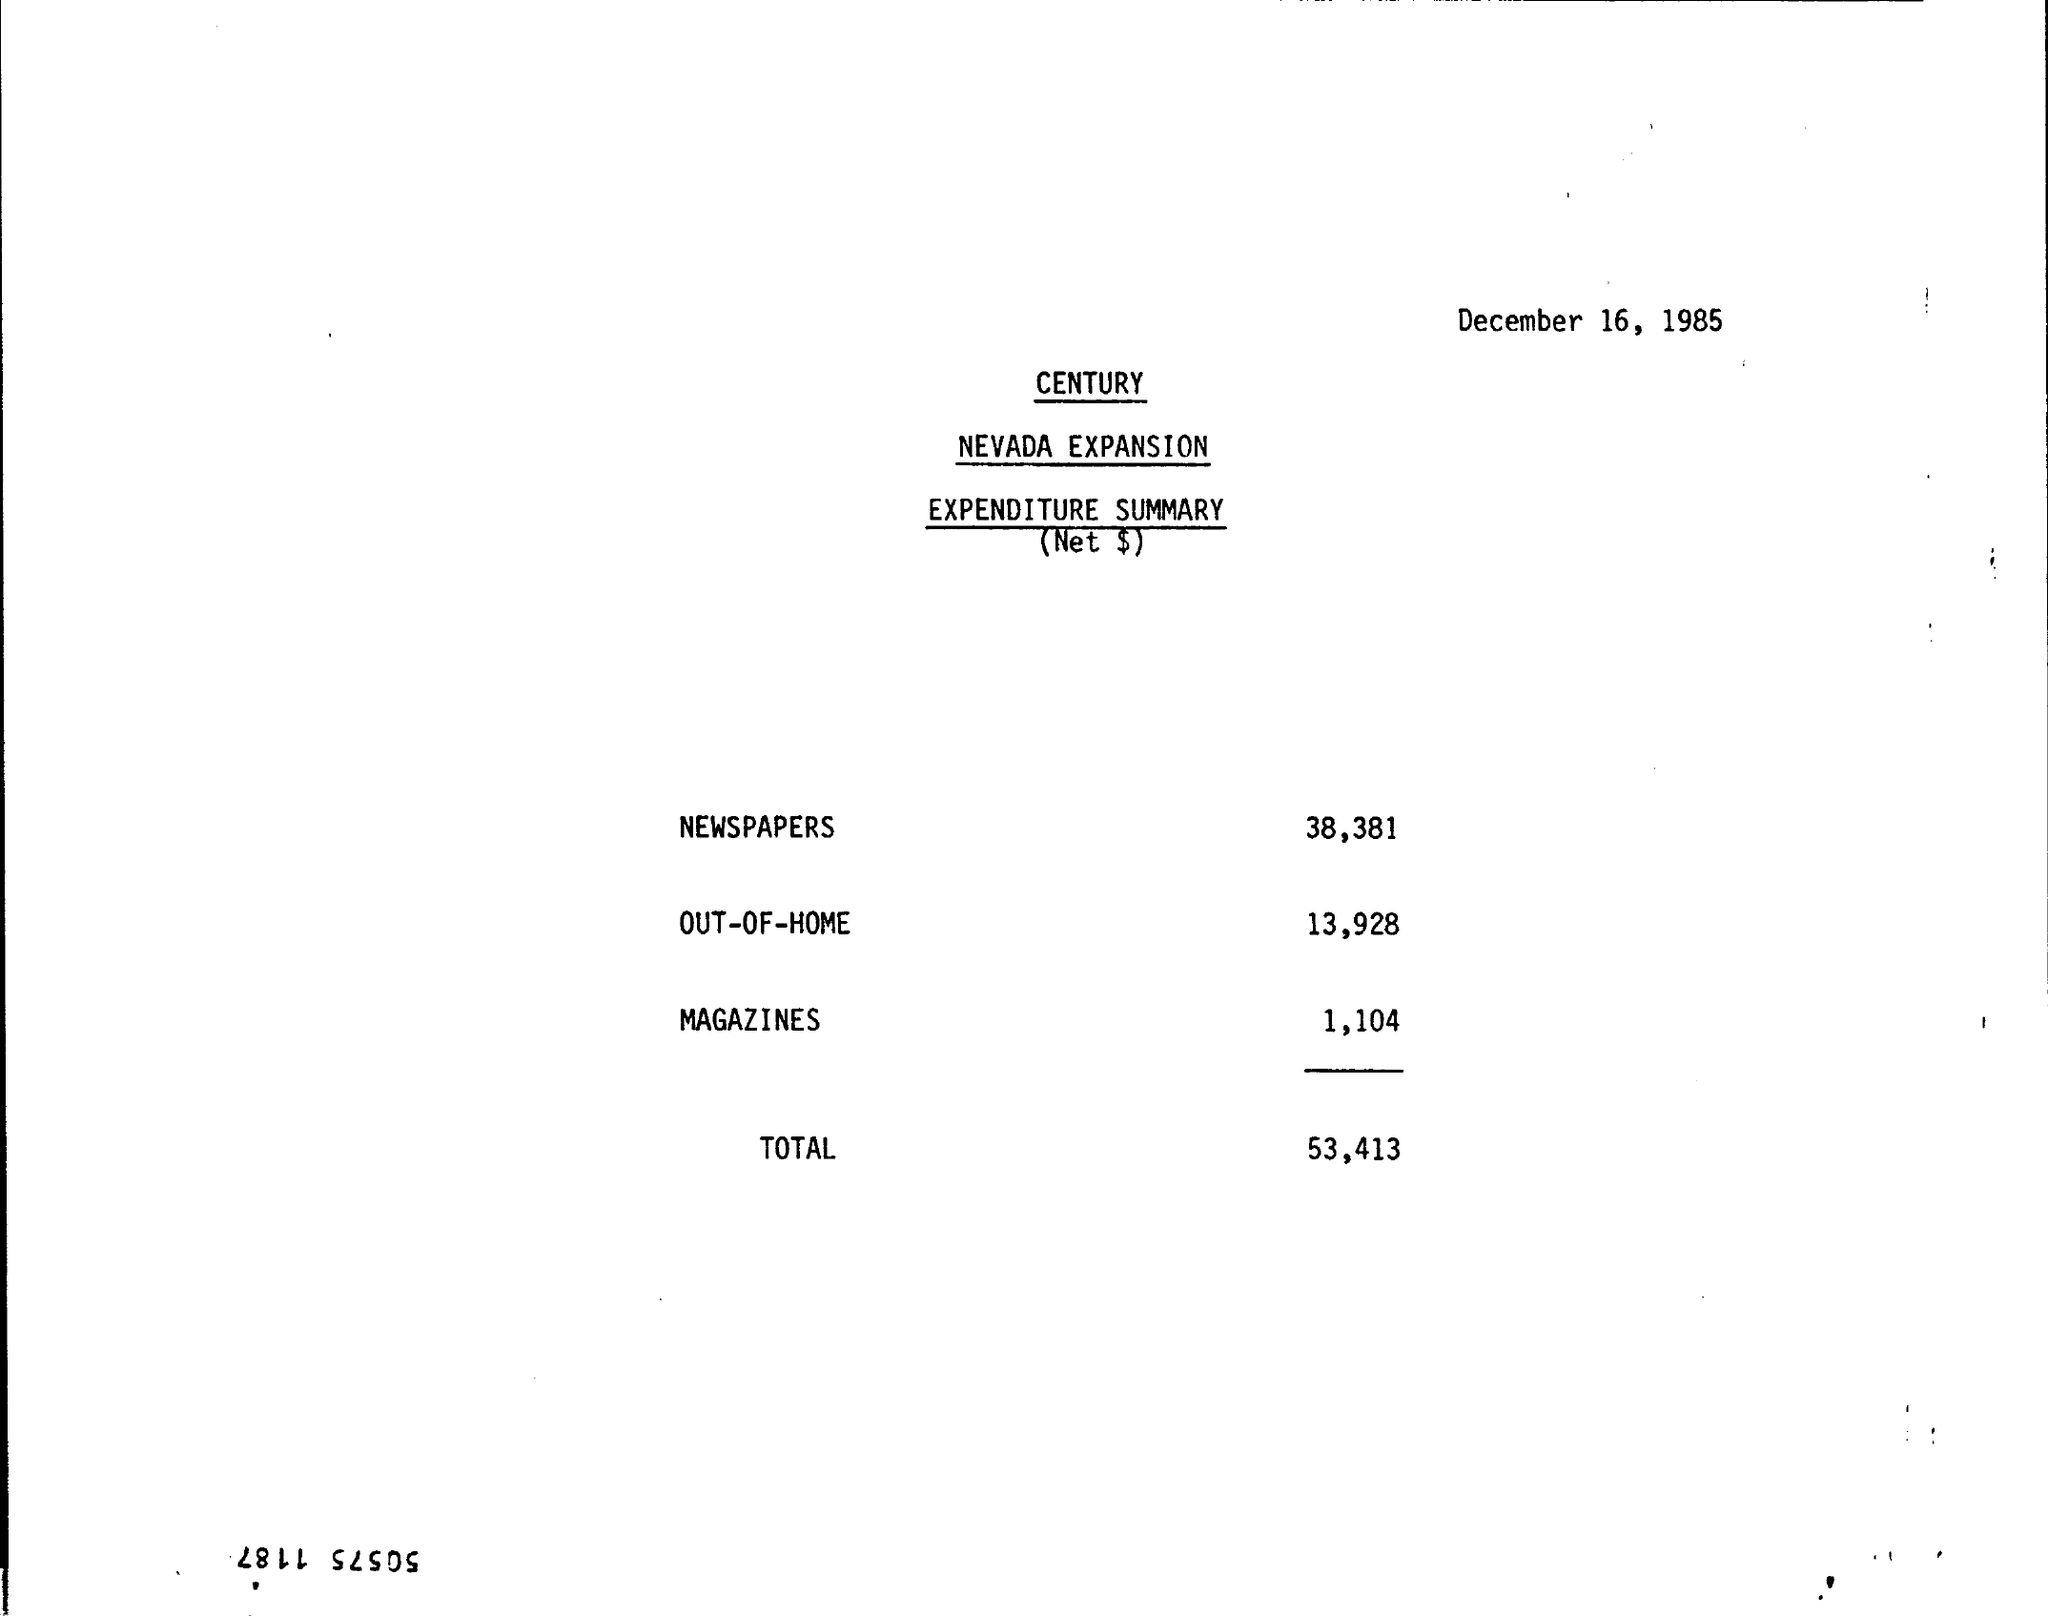What is the Magazines expense? The expenditure for magazines, as part of the Nevada Expansion project on December 16, 1985, was $1,104. 